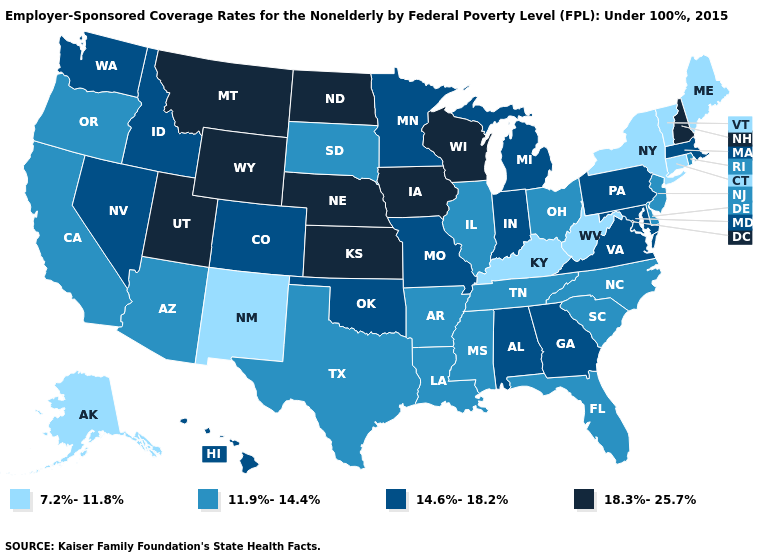What is the value of Nebraska?
Concise answer only. 18.3%-25.7%. What is the lowest value in the South?
Give a very brief answer. 7.2%-11.8%. Is the legend a continuous bar?
Give a very brief answer. No. Name the states that have a value in the range 11.9%-14.4%?
Give a very brief answer. Arizona, Arkansas, California, Delaware, Florida, Illinois, Louisiana, Mississippi, New Jersey, North Carolina, Ohio, Oregon, Rhode Island, South Carolina, South Dakota, Tennessee, Texas. Among the states that border South Dakota , does North Dakota have the lowest value?
Be succinct. No. Name the states that have a value in the range 11.9%-14.4%?
Keep it brief. Arizona, Arkansas, California, Delaware, Florida, Illinois, Louisiana, Mississippi, New Jersey, North Carolina, Ohio, Oregon, Rhode Island, South Carolina, South Dakota, Tennessee, Texas. Among the states that border California , which have the highest value?
Answer briefly. Nevada. Among the states that border Oklahoma , which have the lowest value?
Give a very brief answer. New Mexico. What is the lowest value in states that border South Dakota?
Quick response, please. 14.6%-18.2%. What is the lowest value in the South?
Quick response, please. 7.2%-11.8%. Does Maine have the highest value in the Northeast?
Short answer required. No. What is the lowest value in the USA?
Concise answer only. 7.2%-11.8%. What is the value of New Hampshire?
Concise answer only. 18.3%-25.7%. Name the states that have a value in the range 11.9%-14.4%?
Be succinct. Arizona, Arkansas, California, Delaware, Florida, Illinois, Louisiana, Mississippi, New Jersey, North Carolina, Ohio, Oregon, Rhode Island, South Carolina, South Dakota, Tennessee, Texas. What is the highest value in states that border California?
Concise answer only. 14.6%-18.2%. 